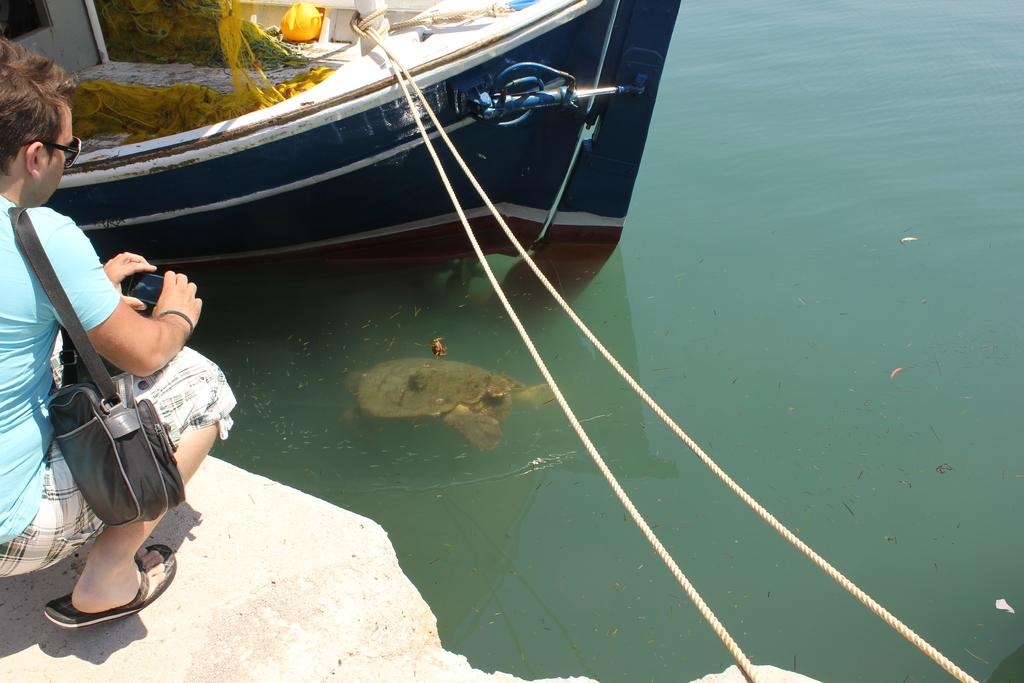What is the person holding in the image? There is a person holding an object in the image. What can be seen on the water in the image? There is a boat on the water in the image. What type of animal is in the water in the image? There is a turtle in the water in the image. What shape is the sock that the person is wearing in the image? There is no sock mentioned or visible in the image. How does the turtle walk on the water in the image? The turtle does not walk on the water in the image; it is swimming in the water. 